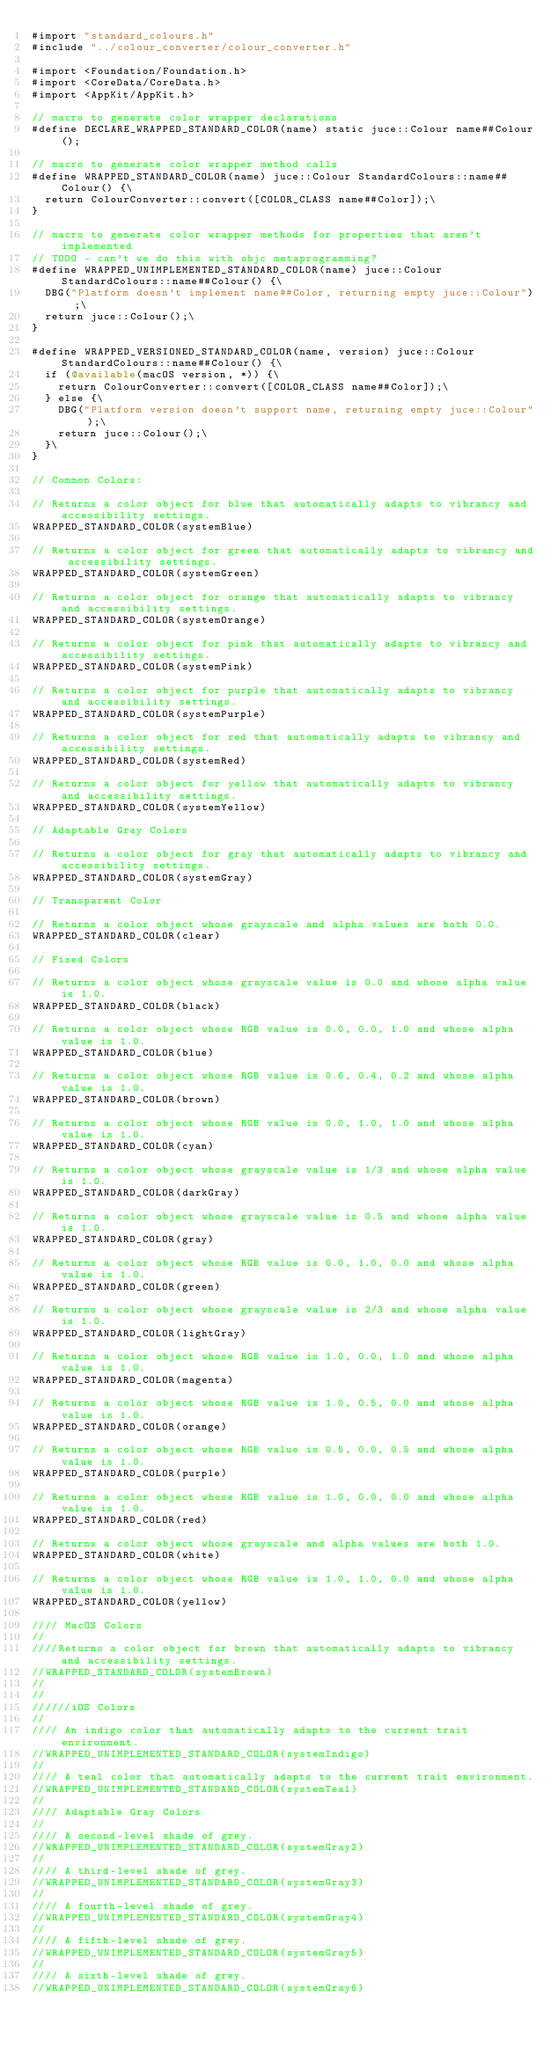Convert code to text. <code><loc_0><loc_0><loc_500><loc_500><_ObjectiveC_>#import "standard_colours.h"
#include "../colour_converter/colour_converter.h"

#import <Foundation/Foundation.h>
#import <CoreData/CoreData.h>
#import <AppKit/AppKit.h>

// macro to generate color wrapper declarations
#define DECLARE_WRAPPED_STANDARD_COLOR(name) static juce::Colour name##Colour();

// macro to generate color wrapper method calls
#define WRAPPED_STANDARD_COLOR(name) juce::Colour StandardColours::name##Colour() {\
  return ColourConverter::convert([COLOR_CLASS name##Color]);\
}

// macro to generate color wrapper methods for properties that aren't implemented
// TODO - can't we do this with objc metaprogramming?
#define WRAPPED_UNIMPLEMENTED_STANDARD_COLOR(name) juce::Colour StandardColours::name##Colour() {\
  DBG("Platform doesn't implement name##Color, returning empty juce::Colour");\
  return juce::Colour();\
}

#define WRAPPED_VERSIONED_STANDARD_COLOR(name, version) juce::Colour StandardColours::name##Colour() {\
  if (@available(macOS version, *)) {\
    return ColourConverter::convert([COLOR_CLASS name##Color]);\
  } else {\
    DBG("Platform version doesn't support name, returning empty juce::Colour");\
    return juce::Colour();\
  }\
}

// Common Colors:

// Returns a color object for blue that automatically adapts to vibrancy and accessibility settings.
WRAPPED_STANDARD_COLOR(systemBlue)

// Returns a color object for green that automatically adapts to vibrancy and accessibility settings.
WRAPPED_STANDARD_COLOR(systemGreen)

// Returns a color object for orange that automatically adapts to vibrancy and accessibility settings.
WRAPPED_STANDARD_COLOR(systemOrange)

// Returns a color object for pink that automatically adapts to vibrancy and accessibility settings.
WRAPPED_STANDARD_COLOR(systemPink)

// Returns a color object for purple that automatically adapts to vibrancy and accessibility settings.
WRAPPED_STANDARD_COLOR(systemPurple)

// Returns a color object for red that automatically adapts to vibrancy and accessibility settings.
WRAPPED_STANDARD_COLOR(systemRed)

// Returns a color object for yellow that automatically adapts to vibrancy and accessibility settings.
WRAPPED_STANDARD_COLOR(systemYellow)

// Adaptable Gray Colors

// Returns a color object for gray that automatically adapts to vibrancy and accessibility settings.
WRAPPED_STANDARD_COLOR(systemGray)

// Transparent Color

// Returns a color object whose grayscale and alpha values are both 0.0.
WRAPPED_STANDARD_COLOR(clear)

// Fixed Colors

// Returns a color object whose grayscale value is 0.0 and whose alpha value is 1.0.
WRAPPED_STANDARD_COLOR(black)

// Returns a color object whose RGB value is 0.0, 0.0, 1.0 and whose alpha value is 1.0.
WRAPPED_STANDARD_COLOR(blue)

// Returns a color object whose RGB value is 0.6, 0.4, 0.2 and whose alpha value is 1.0.
WRAPPED_STANDARD_COLOR(brown)

// Returns a color object whose RGB value is 0.0, 1.0, 1.0 and whose alpha value is 1.0.
WRAPPED_STANDARD_COLOR(cyan)

// Returns a color object whose grayscale value is 1/3 and whose alpha value is 1.0.
WRAPPED_STANDARD_COLOR(darkGray)

// Returns a color object whose grayscale value is 0.5 and whose alpha value is 1.0.
WRAPPED_STANDARD_COLOR(gray)

// Returns a color object whose RGB value is 0.0, 1.0, 0.0 and whose alpha value is 1.0.
WRAPPED_STANDARD_COLOR(green)

// Returns a color object whose grayscale value is 2/3 and whose alpha value is 1.0.
WRAPPED_STANDARD_COLOR(lightGray)

// Returns a color object whose RGB value is 1.0, 0.0, 1.0 and whose alpha value is 1.0.
WRAPPED_STANDARD_COLOR(magenta)

// Returns a color object whose RGB value is 1.0, 0.5, 0.0 and whose alpha value is 1.0.
WRAPPED_STANDARD_COLOR(orange)

// Returns a color object whose RGB value is 0.5, 0.0, 0.5 and whose alpha value is 1.0.
WRAPPED_STANDARD_COLOR(purple)

// Returns a color object whose RGB value is 1.0, 0.0, 0.0 and whose alpha value is 1.0.
WRAPPED_STANDARD_COLOR(red)

// Returns a color object whose grayscale and alpha values are both 1.0.
WRAPPED_STANDARD_COLOR(white)

// Returns a color object whose RGB value is 1.0, 1.0, 0.0 and whose alpha value is 1.0.
WRAPPED_STANDARD_COLOR(yellow)

//// MacOS Colors
//
////Returns a color object for brown that automatically adapts to vibrancy and accessibility settings.
//WRAPPED_STANDARD_COLOR(systemBrown)
//
//
//////iOS Colors
//
//// An indigo color that automatically adapts to the current trait environment.
//WRAPPED_UNIMPLEMENTED_STANDARD_COLOR(systemIndigo)
//
//// A teal color that automatically adapts to the current trait environment.
//WRAPPED_UNIMPLEMENTED_STANDARD_COLOR(systemTeal)
//
//// Adaptable Gray Colors
//
//// A second-level shade of grey.
//WRAPPED_UNIMPLEMENTED_STANDARD_COLOR(systemGray2)
//
//// A third-level shade of grey.
//WRAPPED_UNIMPLEMENTED_STANDARD_COLOR(systemGray3)
//
//// A fourth-level shade of grey.
//WRAPPED_UNIMPLEMENTED_STANDARD_COLOR(systemGray4)
//
//// A fifth-level shade of grey.
//WRAPPED_UNIMPLEMENTED_STANDARD_COLOR(systemGray5)
//
//// A sixth-level shade of grey.
//WRAPPED_UNIMPLEMENTED_STANDARD_COLOR(systemGray6)
</code> 